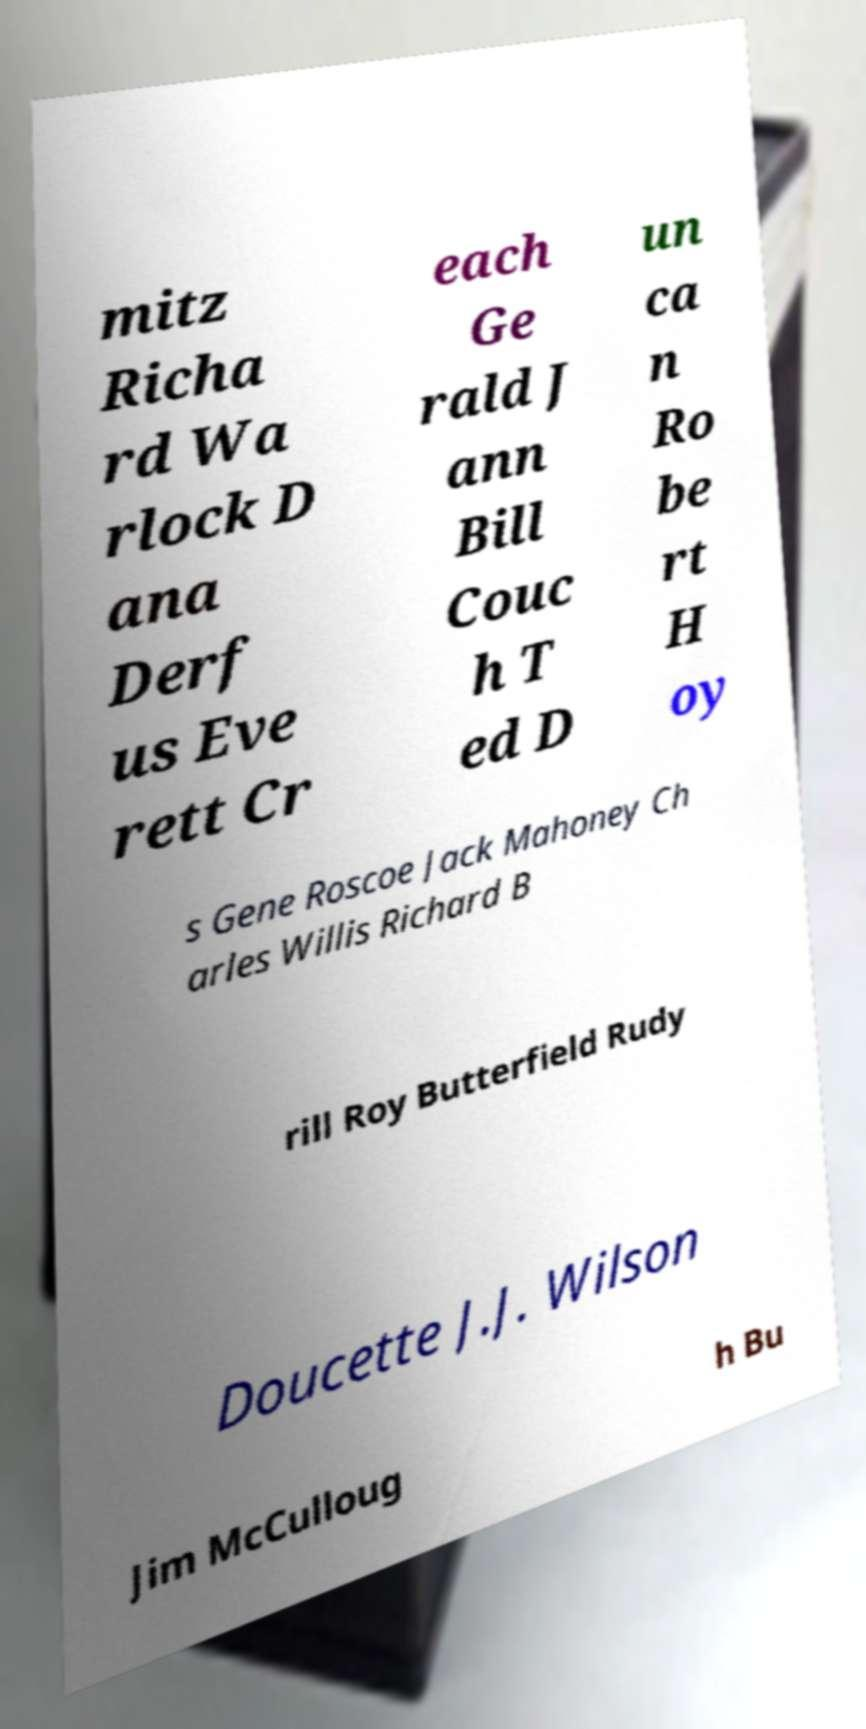Could you assist in decoding the text presented in this image and type it out clearly? mitz Richa rd Wa rlock D ana Derf us Eve rett Cr each Ge rald J ann Bill Couc h T ed D un ca n Ro be rt H oy s Gene Roscoe Jack Mahoney Ch arles Willis Richard B rill Roy Butterfield Rudy Doucette J.J. Wilson Jim McCulloug h Bu 